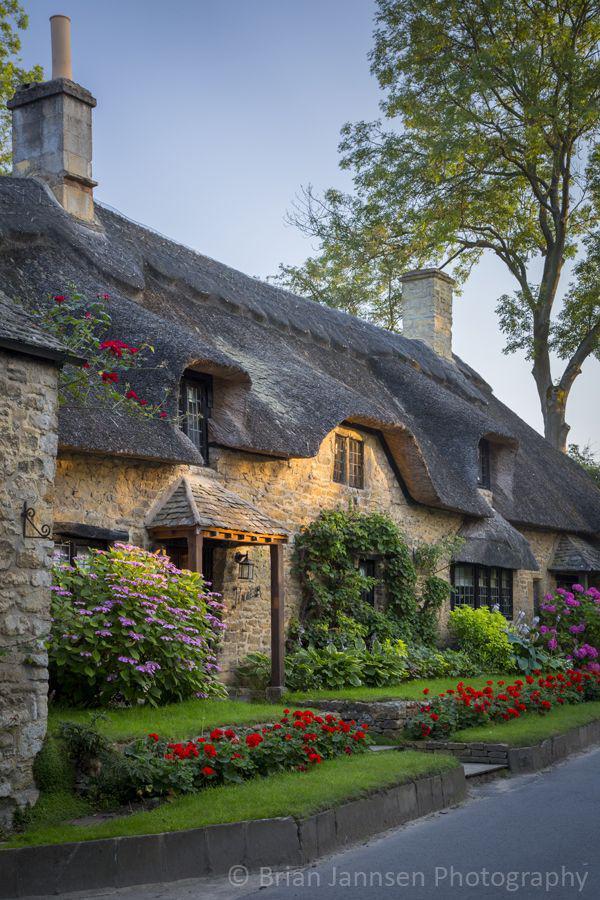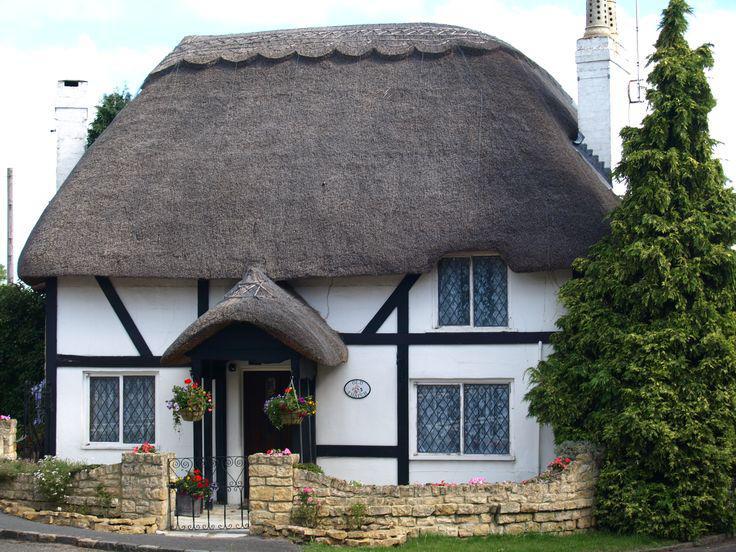The first image is the image on the left, the second image is the image on the right. Considering the images on both sides, is "An image shows the front of a white house with bold dark lines on it forming geometric patterns, a chimney at at least one end, and a thick gray roof with at least one notched cut-out for windows." valid? Answer yes or no. Yes. The first image is the image on the left, the second image is the image on the right. Analyze the images presented: Is the assertion "There are three windows around the black door of the white house." valid? Answer yes or no. Yes. 